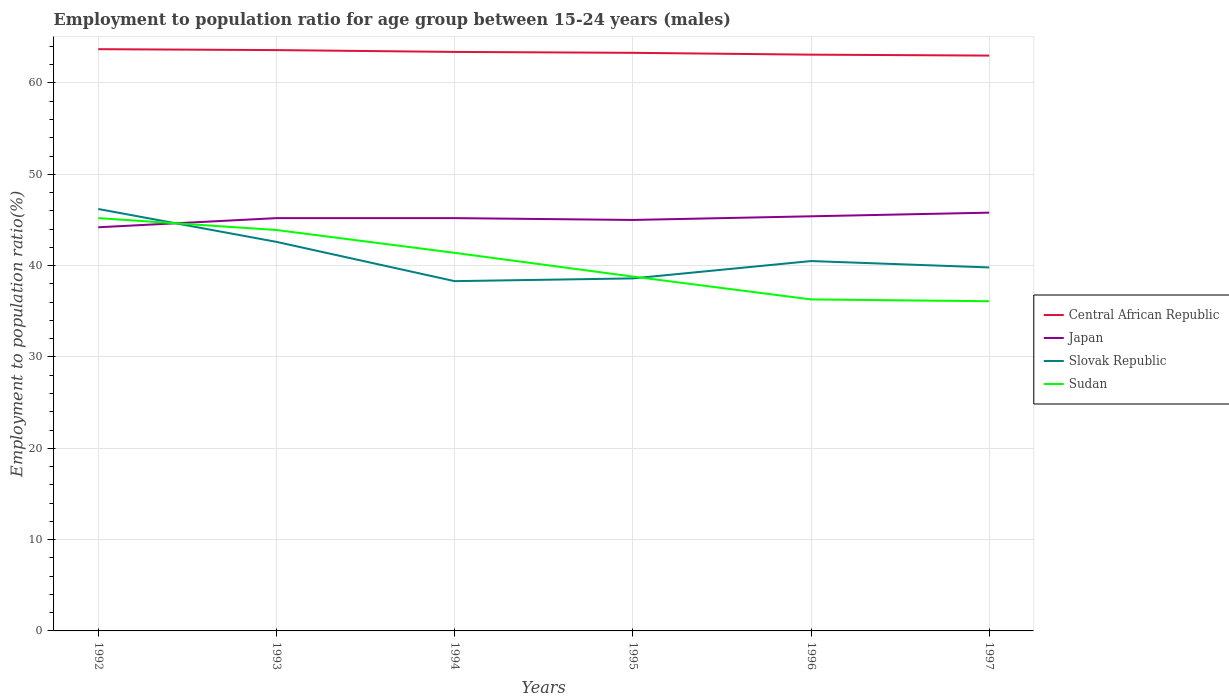Does the line corresponding to Sudan intersect with the line corresponding to Central African Republic?
Offer a very short reply. No. Across all years, what is the maximum employment to population ratio in Japan?
Give a very brief answer. 44.2. In which year was the employment to population ratio in Central African Republic maximum?
Your response must be concise. 1997. What is the total employment to population ratio in Sudan in the graph?
Give a very brief answer. 5.3. What is the difference between the highest and the second highest employment to population ratio in Japan?
Your answer should be very brief. 1.6. Is the employment to population ratio in Slovak Republic strictly greater than the employment to population ratio in Sudan over the years?
Keep it short and to the point. No. What is the difference between two consecutive major ticks on the Y-axis?
Offer a very short reply. 10. Are the values on the major ticks of Y-axis written in scientific E-notation?
Your response must be concise. No. Does the graph contain any zero values?
Provide a succinct answer. No. Does the graph contain grids?
Make the answer very short. Yes. How many legend labels are there?
Make the answer very short. 4. What is the title of the graph?
Give a very brief answer. Employment to population ratio for age group between 15-24 years (males). Does "New Zealand" appear as one of the legend labels in the graph?
Your answer should be very brief. No. What is the Employment to population ratio(%) in Central African Republic in 1992?
Keep it short and to the point. 63.7. What is the Employment to population ratio(%) of Japan in 1992?
Ensure brevity in your answer.  44.2. What is the Employment to population ratio(%) in Slovak Republic in 1992?
Make the answer very short. 46.2. What is the Employment to population ratio(%) in Sudan in 1992?
Provide a short and direct response. 45.2. What is the Employment to population ratio(%) of Central African Republic in 1993?
Give a very brief answer. 63.6. What is the Employment to population ratio(%) in Japan in 1993?
Your answer should be very brief. 45.2. What is the Employment to population ratio(%) in Slovak Republic in 1993?
Make the answer very short. 42.6. What is the Employment to population ratio(%) of Sudan in 1993?
Ensure brevity in your answer.  43.9. What is the Employment to population ratio(%) in Central African Republic in 1994?
Your answer should be compact. 63.4. What is the Employment to population ratio(%) in Japan in 1994?
Your response must be concise. 45.2. What is the Employment to population ratio(%) of Slovak Republic in 1994?
Provide a succinct answer. 38.3. What is the Employment to population ratio(%) of Sudan in 1994?
Offer a terse response. 41.4. What is the Employment to population ratio(%) in Central African Republic in 1995?
Offer a terse response. 63.3. What is the Employment to population ratio(%) in Japan in 1995?
Your response must be concise. 45. What is the Employment to population ratio(%) in Slovak Republic in 1995?
Offer a terse response. 38.6. What is the Employment to population ratio(%) in Sudan in 1995?
Offer a very short reply. 38.8. What is the Employment to population ratio(%) in Central African Republic in 1996?
Your answer should be compact. 63.1. What is the Employment to population ratio(%) in Japan in 1996?
Keep it short and to the point. 45.4. What is the Employment to population ratio(%) in Slovak Republic in 1996?
Give a very brief answer. 40.5. What is the Employment to population ratio(%) in Sudan in 1996?
Your answer should be compact. 36.3. What is the Employment to population ratio(%) of Central African Republic in 1997?
Make the answer very short. 63. What is the Employment to population ratio(%) of Japan in 1997?
Give a very brief answer. 45.8. What is the Employment to population ratio(%) in Slovak Republic in 1997?
Your response must be concise. 39.8. What is the Employment to population ratio(%) of Sudan in 1997?
Offer a terse response. 36.1. Across all years, what is the maximum Employment to population ratio(%) in Central African Republic?
Provide a short and direct response. 63.7. Across all years, what is the maximum Employment to population ratio(%) of Japan?
Give a very brief answer. 45.8. Across all years, what is the maximum Employment to population ratio(%) in Slovak Republic?
Provide a succinct answer. 46.2. Across all years, what is the maximum Employment to population ratio(%) of Sudan?
Give a very brief answer. 45.2. Across all years, what is the minimum Employment to population ratio(%) in Central African Republic?
Keep it short and to the point. 63. Across all years, what is the minimum Employment to population ratio(%) in Japan?
Offer a very short reply. 44.2. Across all years, what is the minimum Employment to population ratio(%) in Slovak Republic?
Offer a terse response. 38.3. Across all years, what is the minimum Employment to population ratio(%) in Sudan?
Your answer should be very brief. 36.1. What is the total Employment to population ratio(%) of Central African Republic in the graph?
Offer a very short reply. 380.1. What is the total Employment to population ratio(%) of Japan in the graph?
Your response must be concise. 270.8. What is the total Employment to population ratio(%) of Slovak Republic in the graph?
Ensure brevity in your answer.  246. What is the total Employment to population ratio(%) of Sudan in the graph?
Make the answer very short. 241.7. What is the difference between the Employment to population ratio(%) in Japan in 1992 and that in 1993?
Your response must be concise. -1. What is the difference between the Employment to population ratio(%) of Sudan in 1992 and that in 1993?
Offer a very short reply. 1.3. What is the difference between the Employment to population ratio(%) of Central African Republic in 1992 and that in 1994?
Make the answer very short. 0.3. What is the difference between the Employment to population ratio(%) in Sudan in 1992 and that in 1994?
Your answer should be very brief. 3.8. What is the difference between the Employment to population ratio(%) of Japan in 1992 and that in 1995?
Make the answer very short. -0.8. What is the difference between the Employment to population ratio(%) in Slovak Republic in 1992 and that in 1995?
Your answer should be compact. 7.6. What is the difference between the Employment to population ratio(%) in Japan in 1992 and that in 1996?
Keep it short and to the point. -1.2. What is the difference between the Employment to population ratio(%) in Central African Republic in 1992 and that in 1997?
Your response must be concise. 0.7. What is the difference between the Employment to population ratio(%) in Japan in 1992 and that in 1997?
Offer a terse response. -1.6. What is the difference between the Employment to population ratio(%) of Central African Republic in 1993 and that in 1994?
Offer a terse response. 0.2. What is the difference between the Employment to population ratio(%) of Japan in 1993 and that in 1994?
Offer a very short reply. 0. What is the difference between the Employment to population ratio(%) in Slovak Republic in 1993 and that in 1994?
Your answer should be very brief. 4.3. What is the difference between the Employment to population ratio(%) of Sudan in 1993 and that in 1994?
Offer a terse response. 2.5. What is the difference between the Employment to population ratio(%) of Central African Republic in 1993 and that in 1995?
Your answer should be very brief. 0.3. What is the difference between the Employment to population ratio(%) of Slovak Republic in 1993 and that in 1995?
Your answer should be very brief. 4. What is the difference between the Employment to population ratio(%) of Central African Republic in 1993 and that in 1996?
Ensure brevity in your answer.  0.5. What is the difference between the Employment to population ratio(%) in Japan in 1993 and that in 1996?
Make the answer very short. -0.2. What is the difference between the Employment to population ratio(%) in Slovak Republic in 1993 and that in 1996?
Your answer should be very brief. 2.1. What is the difference between the Employment to population ratio(%) in Sudan in 1993 and that in 1996?
Give a very brief answer. 7.6. What is the difference between the Employment to population ratio(%) in Central African Republic in 1993 and that in 1997?
Ensure brevity in your answer.  0.6. What is the difference between the Employment to population ratio(%) in Central African Republic in 1994 and that in 1995?
Make the answer very short. 0.1. What is the difference between the Employment to population ratio(%) in Slovak Republic in 1994 and that in 1995?
Give a very brief answer. -0.3. What is the difference between the Employment to population ratio(%) in Central African Republic in 1994 and that in 1996?
Offer a terse response. 0.3. What is the difference between the Employment to population ratio(%) of Japan in 1994 and that in 1996?
Ensure brevity in your answer.  -0.2. What is the difference between the Employment to population ratio(%) of Central African Republic in 1994 and that in 1997?
Offer a terse response. 0.4. What is the difference between the Employment to population ratio(%) of Japan in 1994 and that in 1997?
Your response must be concise. -0.6. What is the difference between the Employment to population ratio(%) of Slovak Republic in 1994 and that in 1997?
Provide a succinct answer. -1.5. What is the difference between the Employment to population ratio(%) of Sudan in 1995 and that in 1996?
Your response must be concise. 2.5. What is the difference between the Employment to population ratio(%) in Sudan in 1995 and that in 1997?
Provide a succinct answer. 2.7. What is the difference between the Employment to population ratio(%) of Japan in 1996 and that in 1997?
Give a very brief answer. -0.4. What is the difference between the Employment to population ratio(%) in Slovak Republic in 1996 and that in 1997?
Your answer should be compact. 0.7. What is the difference between the Employment to population ratio(%) in Central African Republic in 1992 and the Employment to population ratio(%) in Slovak Republic in 1993?
Make the answer very short. 21.1. What is the difference between the Employment to population ratio(%) of Central African Republic in 1992 and the Employment to population ratio(%) of Sudan in 1993?
Your response must be concise. 19.8. What is the difference between the Employment to population ratio(%) of Japan in 1992 and the Employment to population ratio(%) of Slovak Republic in 1993?
Provide a succinct answer. 1.6. What is the difference between the Employment to population ratio(%) in Japan in 1992 and the Employment to population ratio(%) in Sudan in 1993?
Make the answer very short. 0.3. What is the difference between the Employment to population ratio(%) of Slovak Republic in 1992 and the Employment to population ratio(%) of Sudan in 1993?
Provide a succinct answer. 2.3. What is the difference between the Employment to population ratio(%) in Central African Republic in 1992 and the Employment to population ratio(%) in Slovak Republic in 1994?
Your response must be concise. 25.4. What is the difference between the Employment to population ratio(%) in Central African Republic in 1992 and the Employment to population ratio(%) in Sudan in 1994?
Ensure brevity in your answer.  22.3. What is the difference between the Employment to population ratio(%) in Japan in 1992 and the Employment to population ratio(%) in Slovak Republic in 1994?
Keep it short and to the point. 5.9. What is the difference between the Employment to population ratio(%) in Central African Republic in 1992 and the Employment to population ratio(%) in Slovak Republic in 1995?
Keep it short and to the point. 25.1. What is the difference between the Employment to population ratio(%) in Central African Republic in 1992 and the Employment to population ratio(%) in Sudan in 1995?
Ensure brevity in your answer.  24.9. What is the difference between the Employment to population ratio(%) in Japan in 1992 and the Employment to population ratio(%) in Sudan in 1995?
Provide a short and direct response. 5.4. What is the difference between the Employment to population ratio(%) in Central African Republic in 1992 and the Employment to population ratio(%) in Slovak Republic in 1996?
Make the answer very short. 23.2. What is the difference between the Employment to population ratio(%) of Central African Republic in 1992 and the Employment to population ratio(%) of Sudan in 1996?
Provide a succinct answer. 27.4. What is the difference between the Employment to population ratio(%) in Japan in 1992 and the Employment to population ratio(%) in Slovak Republic in 1996?
Make the answer very short. 3.7. What is the difference between the Employment to population ratio(%) in Japan in 1992 and the Employment to population ratio(%) in Sudan in 1996?
Ensure brevity in your answer.  7.9. What is the difference between the Employment to population ratio(%) of Central African Republic in 1992 and the Employment to population ratio(%) of Slovak Republic in 1997?
Provide a short and direct response. 23.9. What is the difference between the Employment to population ratio(%) in Central African Republic in 1992 and the Employment to population ratio(%) in Sudan in 1997?
Ensure brevity in your answer.  27.6. What is the difference between the Employment to population ratio(%) in Japan in 1992 and the Employment to population ratio(%) in Slovak Republic in 1997?
Give a very brief answer. 4.4. What is the difference between the Employment to population ratio(%) of Japan in 1992 and the Employment to population ratio(%) of Sudan in 1997?
Your response must be concise. 8.1. What is the difference between the Employment to population ratio(%) in Slovak Republic in 1992 and the Employment to population ratio(%) in Sudan in 1997?
Provide a short and direct response. 10.1. What is the difference between the Employment to population ratio(%) of Central African Republic in 1993 and the Employment to population ratio(%) of Slovak Republic in 1994?
Provide a succinct answer. 25.3. What is the difference between the Employment to population ratio(%) of Central African Republic in 1993 and the Employment to population ratio(%) of Sudan in 1994?
Your answer should be compact. 22.2. What is the difference between the Employment to population ratio(%) of Japan in 1993 and the Employment to population ratio(%) of Sudan in 1994?
Your response must be concise. 3.8. What is the difference between the Employment to population ratio(%) of Central African Republic in 1993 and the Employment to population ratio(%) of Slovak Republic in 1995?
Offer a very short reply. 25. What is the difference between the Employment to population ratio(%) of Central African Republic in 1993 and the Employment to population ratio(%) of Sudan in 1995?
Provide a succinct answer. 24.8. What is the difference between the Employment to population ratio(%) of Slovak Republic in 1993 and the Employment to population ratio(%) of Sudan in 1995?
Offer a terse response. 3.8. What is the difference between the Employment to population ratio(%) of Central African Republic in 1993 and the Employment to population ratio(%) of Japan in 1996?
Provide a short and direct response. 18.2. What is the difference between the Employment to population ratio(%) in Central African Republic in 1993 and the Employment to population ratio(%) in Slovak Republic in 1996?
Provide a succinct answer. 23.1. What is the difference between the Employment to population ratio(%) in Central African Republic in 1993 and the Employment to population ratio(%) in Sudan in 1996?
Give a very brief answer. 27.3. What is the difference between the Employment to population ratio(%) of Japan in 1993 and the Employment to population ratio(%) of Sudan in 1996?
Keep it short and to the point. 8.9. What is the difference between the Employment to population ratio(%) in Central African Republic in 1993 and the Employment to population ratio(%) in Japan in 1997?
Ensure brevity in your answer.  17.8. What is the difference between the Employment to population ratio(%) in Central African Republic in 1993 and the Employment to population ratio(%) in Slovak Republic in 1997?
Keep it short and to the point. 23.8. What is the difference between the Employment to population ratio(%) of Japan in 1993 and the Employment to population ratio(%) of Slovak Republic in 1997?
Provide a succinct answer. 5.4. What is the difference between the Employment to population ratio(%) of Central African Republic in 1994 and the Employment to population ratio(%) of Japan in 1995?
Your answer should be compact. 18.4. What is the difference between the Employment to population ratio(%) of Central African Republic in 1994 and the Employment to population ratio(%) of Slovak Republic in 1995?
Offer a terse response. 24.8. What is the difference between the Employment to population ratio(%) of Central African Republic in 1994 and the Employment to population ratio(%) of Sudan in 1995?
Offer a very short reply. 24.6. What is the difference between the Employment to population ratio(%) of Japan in 1994 and the Employment to population ratio(%) of Slovak Republic in 1995?
Offer a terse response. 6.6. What is the difference between the Employment to population ratio(%) in Japan in 1994 and the Employment to population ratio(%) in Sudan in 1995?
Give a very brief answer. 6.4. What is the difference between the Employment to population ratio(%) in Central African Republic in 1994 and the Employment to population ratio(%) in Slovak Republic in 1996?
Provide a succinct answer. 22.9. What is the difference between the Employment to population ratio(%) of Central African Republic in 1994 and the Employment to population ratio(%) of Sudan in 1996?
Your answer should be compact. 27.1. What is the difference between the Employment to population ratio(%) of Japan in 1994 and the Employment to population ratio(%) of Slovak Republic in 1996?
Offer a terse response. 4.7. What is the difference between the Employment to population ratio(%) in Slovak Republic in 1994 and the Employment to population ratio(%) in Sudan in 1996?
Provide a short and direct response. 2. What is the difference between the Employment to population ratio(%) in Central African Republic in 1994 and the Employment to population ratio(%) in Slovak Republic in 1997?
Provide a succinct answer. 23.6. What is the difference between the Employment to population ratio(%) in Central African Republic in 1994 and the Employment to population ratio(%) in Sudan in 1997?
Provide a succinct answer. 27.3. What is the difference between the Employment to population ratio(%) in Japan in 1994 and the Employment to population ratio(%) in Sudan in 1997?
Provide a succinct answer. 9.1. What is the difference between the Employment to population ratio(%) of Central African Republic in 1995 and the Employment to population ratio(%) of Slovak Republic in 1996?
Provide a succinct answer. 22.8. What is the difference between the Employment to population ratio(%) in Central African Republic in 1995 and the Employment to population ratio(%) in Sudan in 1996?
Offer a very short reply. 27. What is the difference between the Employment to population ratio(%) of Japan in 1995 and the Employment to population ratio(%) of Sudan in 1996?
Your answer should be compact. 8.7. What is the difference between the Employment to population ratio(%) in Slovak Republic in 1995 and the Employment to population ratio(%) in Sudan in 1996?
Keep it short and to the point. 2.3. What is the difference between the Employment to population ratio(%) in Central African Republic in 1995 and the Employment to population ratio(%) in Japan in 1997?
Provide a succinct answer. 17.5. What is the difference between the Employment to population ratio(%) in Central African Republic in 1995 and the Employment to population ratio(%) in Slovak Republic in 1997?
Give a very brief answer. 23.5. What is the difference between the Employment to population ratio(%) in Central African Republic in 1995 and the Employment to population ratio(%) in Sudan in 1997?
Provide a short and direct response. 27.2. What is the difference between the Employment to population ratio(%) in Japan in 1995 and the Employment to population ratio(%) in Slovak Republic in 1997?
Keep it short and to the point. 5.2. What is the difference between the Employment to population ratio(%) of Japan in 1995 and the Employment to population ratio(%) of Sudan in 1997?
Give a very brief answer. 8.9. What is the difference between the Employment to population ratio(%) of Slovak Republic in 1995 and the Employment to population ratio(%) of Sudan in 1997?
Offer a terse response. 2.5. What is the difference between the Employment to population ratio(%) in Central African Republic in 1996 and the Employment to population ratio(%) in Japan in 1997?
Offer a very short reply. 17.3. What is the difference between the Employment to population ratio(%) of Central African Republic in 1996 and the Employment to population ratio(%) of Slovak Republic in 1997?
Make the answer very short. 23.3. What is the difference between the Employment to population ratio(%) in Japan in 1996 and the Employment to population ratio(%) in Sudan in 1997?
Your answer should be very brief. 9.3. What is the difference between the Employment to population ratio(%) of Slovak Republic in 1996 and the Employment to population ratio(%) of Sudan in 1997?
Ensure brevity in your answer.  4.4. What is the average Employment to population ratio(%) of Central African Republic per year?
Provide a succinct answer. 63.35. What is the average Employment to population ratio(%) in Japan per year?
Ensure brevity in your answer.  45.13. What is the average Employment to population ratio(%) in Slovak Republic per year?
Offer a very short reply. 41. What is the average Employment to population ratio(%) in Sudan per year?
Offer a terse response. 40.28. In the year 1992, what is the difference between the Employment to population ratio(%) in Central African Republic and Employment to population ratio(%) in Slovak Republic?
Your answer should be compact. 17.5. In the year 1992, what is the difference between the Employment to population ratio(%) in Japan and Employment to population ratio(%) in Slovak Republic?
Provide a short and direct response. -2. In the year 1992, what is the difference between the Employment to population ratio(%) in Slovak Republic and Employment to population ratio(%) in Sudan?
Make the answer very short. 1. In the year 1993, what is the difference between the Employment to population ratio(%) in Central African Republic and Employment to population ratio(%) in Japan?
Your response must be concise. 18.4. In the year 1993, what is the difference between the Employment to population ratio(%) in Japan and Employment to population ratio(%) in Sudan?
Provide a succinct answer. 1.3. In the year 1993, what is the difference between the Employment to population ratio(%) of Slovak Republic and Employment to population ratio(%) of Sudan?
Your answer should be very brief. -1.3. In the year 1994, what is the difference between the Employment to population ratio(%) of Central African Republic and Employment to population ratio(%) of Japan?
Your response must be concise. 18.2. In the year 1994, what is the difference between the Employment to population ratio(%) of Central African Republic and Employment to population ratio(%) of Slovak Republic?
Offer a very short reply. 25.1. In the year 1994, what is the difference between the Employment to population ratio(%) in Central African Republic and Employment to population ratio(%) in Sudan?
Keep it short and to the point. 22. In the year 1994, what is the difference between the Employment to population ratio(%) in Japan and Employment to population ratio(%) in Slovak Republic?
Offer a very short reply. 6.9. In the year 1995, what is the difference between the Employment to population ratio(%) of Central African Republic and Employment to population ratio(%) of Slovak Republic?
Make the answer very short. 24.7. In the year 1995, what is the difference between the Employment to population ratio(%) in Central African Republic and Employment to population ratio(%) in Sudan?
Provide a succinct answer. 24.5. In the year 1995, what is the difference between the Employment to population ratio(%) of Japan and Employment to population ratio(%) of Slovak Republic?
Provide a short and direct response. 6.4. In the year 1995, what is the difference between the Employment to population ratio(%) of Japan and Employment to population ratio(%) of Sudan?
Give a very brief answer. 6.2. In the year 1995, what is the difference between the Employment to population ratio(%) in Slovak Republic and Employment to population ratio(%) in Sudan?
Your answer should be very brief. -0.2. In the year 1996, what is the difference between the Employment to population ratio(%) in Central African Republic and Employment to population ratio(%) in Slovak Republic?
Keep it short and to the point. 22.6. In the year 1996, what is the difference between the Employment to population ratio(%) of Central African Republic and Employment to population ratio(%) of Sudan?
Give a very brief answer. 26.8. In the year 1996, what is the difference between the Employment to population ratio(%) of Japan and Employment to population ratio(%) of Slovak Republic?
Make the answer very short. 4.9. In the year 1996, what is the difference between the Employment to population ratio(%) in Slovak Republic and Employment to population ratio(%) in Sudan?
Keep it short and to the point. 4.2. In the year 1997, what is the difference between the Employment to population ratio(%) in Central African Republic and Employment to population ratio(%) in Japan?
Offer a terse response. 17.2. In the year 1997, what is the difference between the Employment to population ratio(%) of Central African Republic and Employment to population ratio(%) of Slovak Republic?
Provide a succinct answer. 23.2. In the year 1997, what is the difference between the Employment to population ratio(%) in Central African Republic and Employment to population ratio(%) in Sudan?
Provide a short and direct response. 26.9. What is the ratio of the Employment to population ratio(%) in Central African Republic in 1992 to that in 1993?
Offer a very short reply. 1. What is the ratio of the Employment to population ratio(%) of Japan in 1992 to that in 1993?
Offer a very short reply. 0.98. What is the ratio of the Employment to population ratio(%) in Slovak Republic in 1992 to that in 1993?
Ensure brevity in your answer.  1.08. What is the ratio of the Employment to population ratio(%) in Sudan in 1992 to that in 1993?
Ensure brevity in your answer.  1.03. What is the ratio of the Employment to population ratio(%) in Japan in 1992 to that in 1994?
Your answer should be compact. 0.98. What is the ratio of the Employment to population ratio(%) in Slovak Republic in 1992 to that in 1994?
Ensure brevity in your answer.  1.21. What is the ratio of the Employment to population ratio(%) in Sudan in 1992 to that in 1994?
Give a very brief answer. 1.09. What is the ratio of the Employment to population ratio(%) of Japan in 1992 to that in 1995?
Give a very brief answer. 0.98. What is the ratio of the Employment to population ratio(%) in Slovak Republic in 1992 to that in 1995?
Your answer should be very brief. 1.2. What is the ratio of the Employment to population ratio(%) of Sudan in 1992 to that in 1995?
Ensure brevity in your answer.  1.16. What is the ratio of the Employment to population ratio(%) of Central African Republic in 1992 to that in 1996?
Offer a very short reply. 1.01. What is the ratio of the Employment to population ratio(%) in Japan in 1992 to that in 1996?
Your answer should be compact. 0.97. What is the ratio of the Employment to population ratio(%) in Slovak Republic in 1992 to that in 1996?
Offer a terse response. 1.14. What is the ratio of the Employment to population ratio(%) of Sudan in 1992 to that in 1996?
Offer a terse response. 1.25. What is the ratio of the Employment to population ratio(%) in Central African Republic in 1992 to that in 1997?
Provide a short and direct response. 1.01. What is the ratio of the Employment to population ratio(%) in Japan in 1992 to that in 1997?
Give a very brief answer. 0.97. What is the ratio of the Employment to population ratio(%) of Slovak Republic in 1992 to that in 1997?
Provide a succinct answer. 1.16. What is the ratio of the Employment to population ratio(%) in Sudan in 1992 to that in 1997?
Your response must be concise. 1.25. What is the ratio of the Employment to population ratio(%) in Central African Republic in 1993 to that in 1994?
Provide a succinct answer. 1. What is the ratio of the Employment to population ratio(%) in Slovak Republic in 1993 to that in 1994?
Provide a succinct answer. 1.11. What is the ratio of the Employment to population ratio(%) of Sudan in 1993 to that in 1994?
Ensure brevity in your answer.  1.06. What is the ratio of the Employment to population ratio(%) in Japan in 1993 to that in 1995?
Your response must be concise. 1. What is the ratio of the Employment to population ratio(%) in Slovak Republic in 1993 to that in 1995?
Offer a very short reply. 1.1. What is the ratio of the Employment to population ratio(%) of Sudan in 1993 to that in 1995?
Provide a succinct answer. 1.13. What is the ratio of the Employment to population ratio(%) of Central African Republic in 1993 to that in 1996?
Your answer should be compact. 1.01. What is the ratio of the Employment to population ratio(%) of Japan in 1993 to that in 1996?
Provide a succinct answer. 1. What is the ratio of the Employment to population ratio(%) of Slovak Republic in 1993 to that in 1996?
Provide a short and direct response. 1.05. What is the ratio of the Employment to population ratio(%) of Sudan in 1993 to that in 1996?
Make the answer very short. 1.21. What is the ratio of the Employment to population ratio(%) in Central African Republic in 1993 to that in 1997?
Your answer should be compact. 1.01. What is the ratio of the Employment to population ratio(%) in Japan in 1993 to that in 1997?
Provide a succinct answer. 0.99. What is the ratio of the Employment to population ratio(%) in Slovak Republic in 1993 to that in 1997?
Your answer should be very brief. 1.07. What is the ratio of the Employment to population ratio(%) in Sudan in 1993 to that in 1997?
Your response must be concise. 1.22. What is the ratio of the Employment to population ratio(%) of Central African Republic in 1994 to that in 1995?
Offer a very short reply. 1. What is the ratio of the Employment to population ratio(%) in Japan in 1994 to that in 1995?
Provide a short and direct response. 1. What is the ratio of the Employment to population ratio(%) in Sudan in 1994 to that in 1995?
Your response must be concise. 1.07. What is the ratio of the Employment to population ratio(%) in Central African Republic in 1994 to that in 1996?
Give a very brief answer. 1. What is the ratio of the Employment to population ratio(%) of Japan in 1994 to that in 1996?
Provide a short and direct response. 1. What is the ratio of the Employment to population ratio(%) in Slovak Republic in 1994 to that in 1996?
Provide a short and direct response. 0.95. What is the ratio of the Employment to population ratio(%) of Sudan in 1994 to that in 1996?
Your answer should be very brief. 1.14. What is the ratio of the Employment to population ratio(%) of Central African Republic in 1994 to that in 1997?
Keep it short and to the point. 1.01. What is the ratio of the Employment to population ratio(%) in Japan in 1994 to that in 1997?
Your answer should be compact. 0.99. What is the ratio of the Employment to population ratio(%) in Slovak Republic in 1994 to that in 1997?
Give a very brief answer. 0.96. What is the ratio of the Employment to population ratio(%) of Sudan in 1994 to that in 1997?
Offer a very short reply. 1.15. What is the ratio of the Employment to population ratio(%) in Slovak Republic in 1995 to that in 1996?
Provide a short and direct response. 0.95. What is the ratio of the Employment to population ratio(%) of Sudan in 1995 to that in 1996?
Keep it short and to the point. 1.07. What is the ratio of the Employment to population ratio(%) in Japan in 1995 to that in 1997?
Offer a terse response. 0.98. What is the ratio of the Employment to population ratio(%) of Slovak Republic in 1995 to that in 1997?
Ensure brevity in your answer.  0.97. What is the ratio of the Employment to population ratio(%) in Sudan in 1995 to that in 1997?
Make the answer very short. 1.07. What is the ratio of the Employment to population ratio(%) of Central African Republic in 1996 to that in 1997?
Offer a very short reply. 1. What is the ratio of the Employment to population ratio(%) of Slovak Republic in 1996 to that in 1997?
Offer a terse response. 1.02. What is the difference between the highest and the second highest Employment to population ratio(%) of Japan?
Offer a terse response. 0.4. What is the difference between the highest and the lowest Employment to population ratio(%) of Slovak Republic?
Make the answer very short. 7.9. 